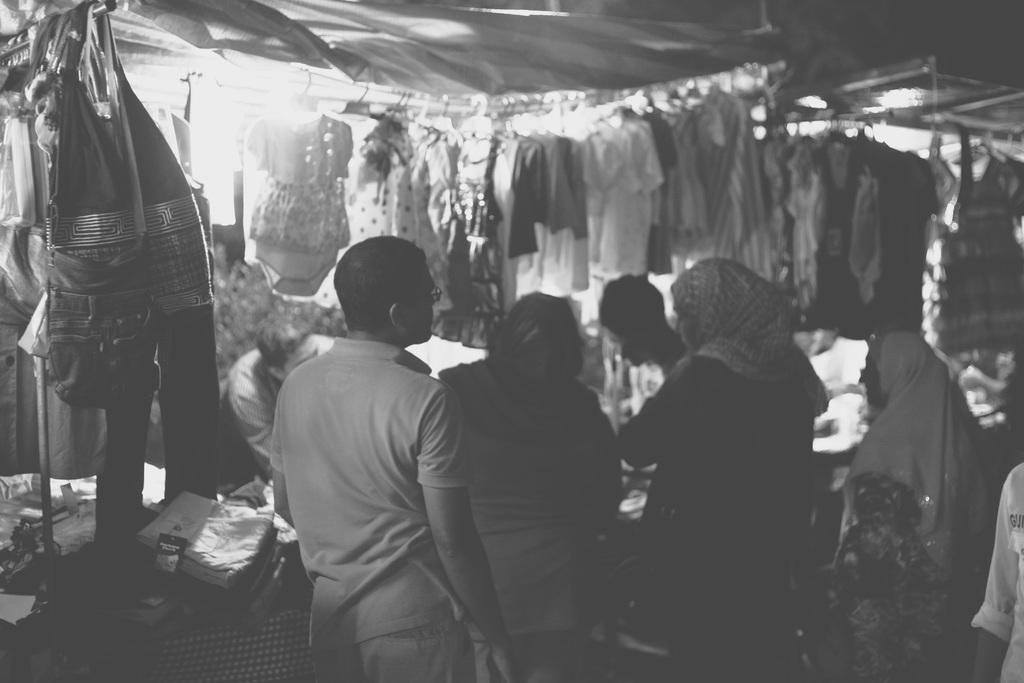What is the color scheme of the image? The image is black and white. What type of store is depicted in the image? There is a cloth stall in the image. What are the people in front of the store doing? The people are standing in front of the store and buying clothes. What type of club is being used by the people in the image? There is no club present in the image; it features a cloth stall and people buying clothes. What type of competition is taking place in the image? There is no competition present in the image; it features a cloth stall and people buying clothes. 